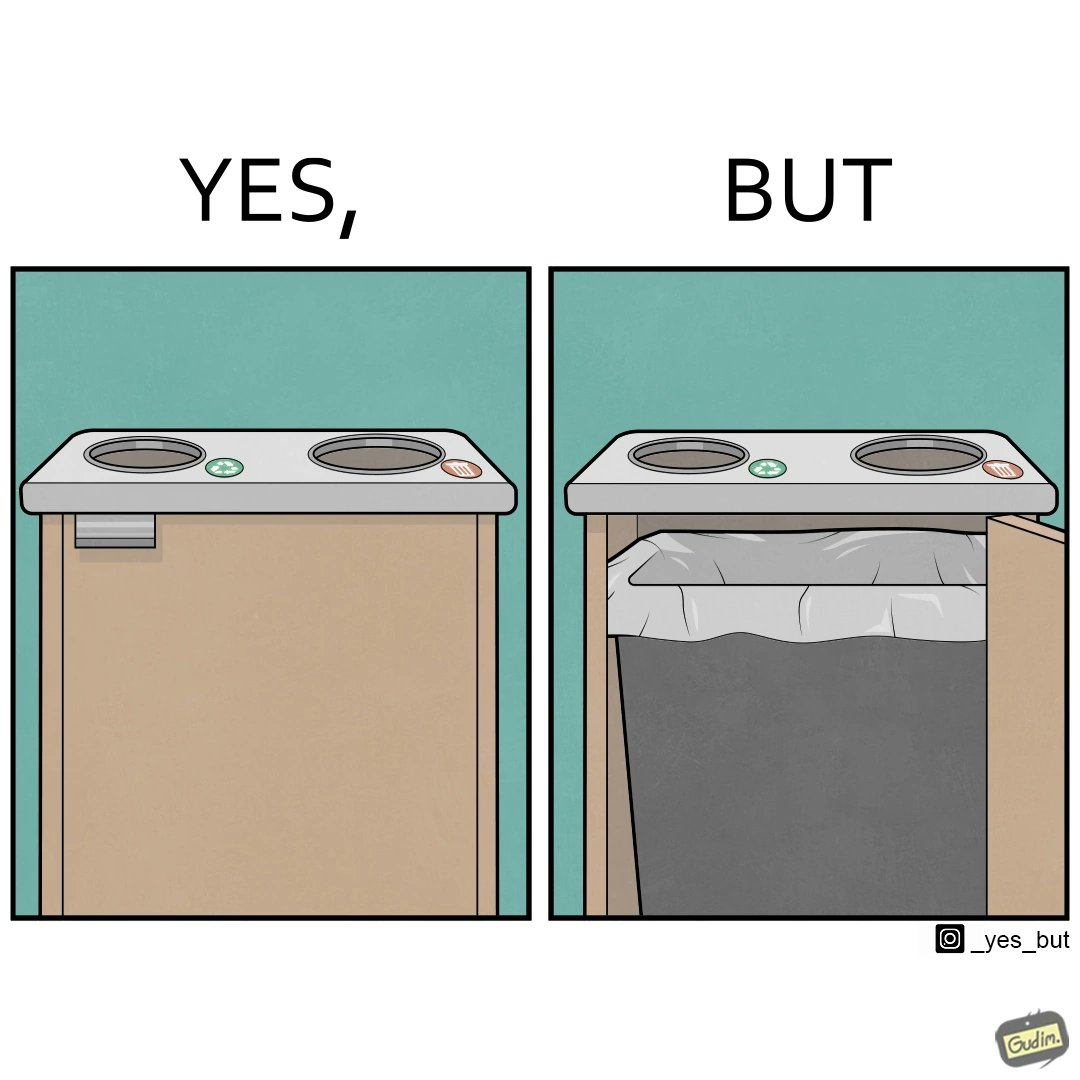Is this image satirical or non-satirical? Yes, this image is satirical. 